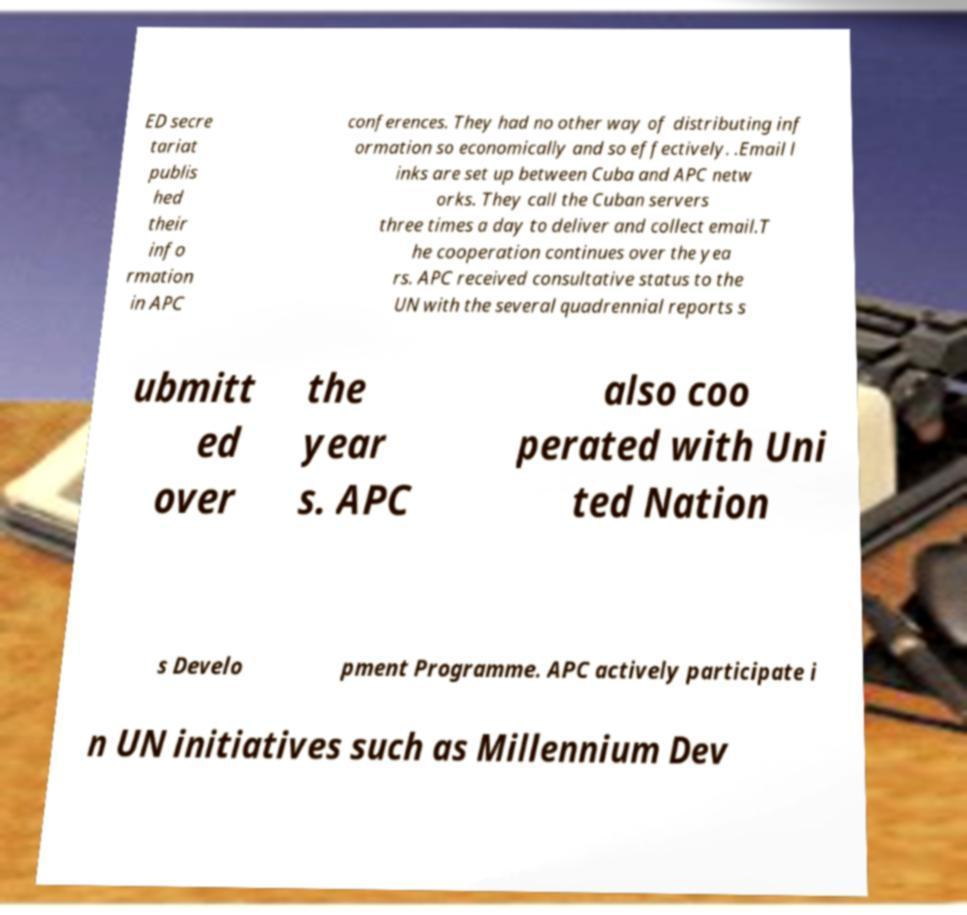What messages or text are displayed in this image? I need them in a readable, typed format. ED secre tariat publis hed their info rmation in APC conferences. They had no other way of distributing inf ormation so economically and so effectively. .Email l inks are set up between Cuba and APC netw orks. They call the Cuban servers three times a day to deliver and collect email.T he cooperation continues over the yea rs. APC received consultative status to the UN with the several quadrennial reports s ubmitt ed over the year s. APC also coo perated with Uni ted Nation s Develo pment Programme. APC actively participate i n UN initiatives such as Millennium Dev 